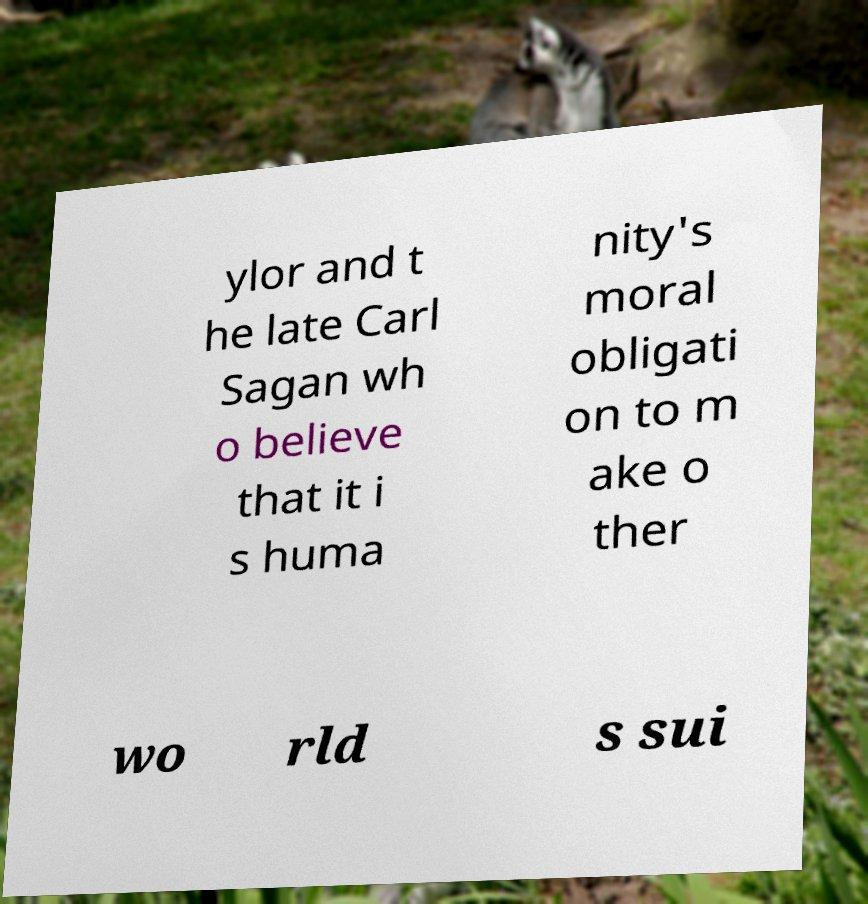Could you extract and type out the text from this image? ylor and t he late Carl Sagan wh o believe that it i s huma nity's moral obligati on to m ake o ther wo rld s sui 